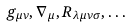<formula> <loc_0><loc_0><loc_500><loc_500>g _ { \mu \nu } , \nabla _ { \mu } , R _ { \lambda \mu \nu \sigma } , \dots</formula> 